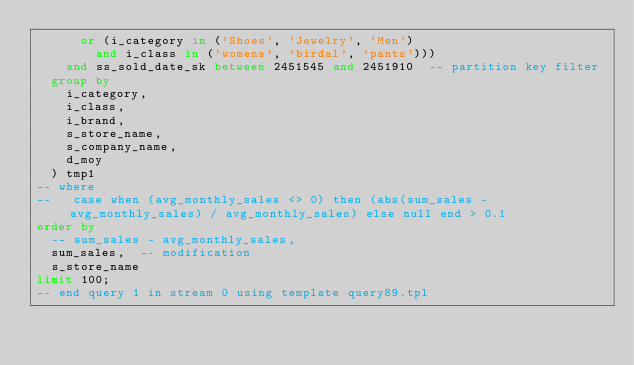Convert code to text. <code><loc_0><loc_0><loc_500><loc_500><_SQL_>      or (i_category in ('Shoes', 'Jewelry', 'Men')
        and i_class in ('womens', 'birdal', 'pants')))
    and ss_sold_date_sk between 2451545 and 2451910  -- partition key filter
  group by
    i_category,
    i_class,
    i_brand,
    s_store_name,
    s_company_name,
    d_moy
  ) tmp1
-- where
--   case when (avg_monthly_sales <> 0) then (abs(sum_sales - avg_monthly_sales) / avg_monthly_sales) else null end > 0.1
order by
  -- sum_sales - avg_monthly_sales,
  sum_sales,  -- modification
  s_store_name
limit 100;
-- end query 1 in stream 0 using template query89.tpl
</code> 